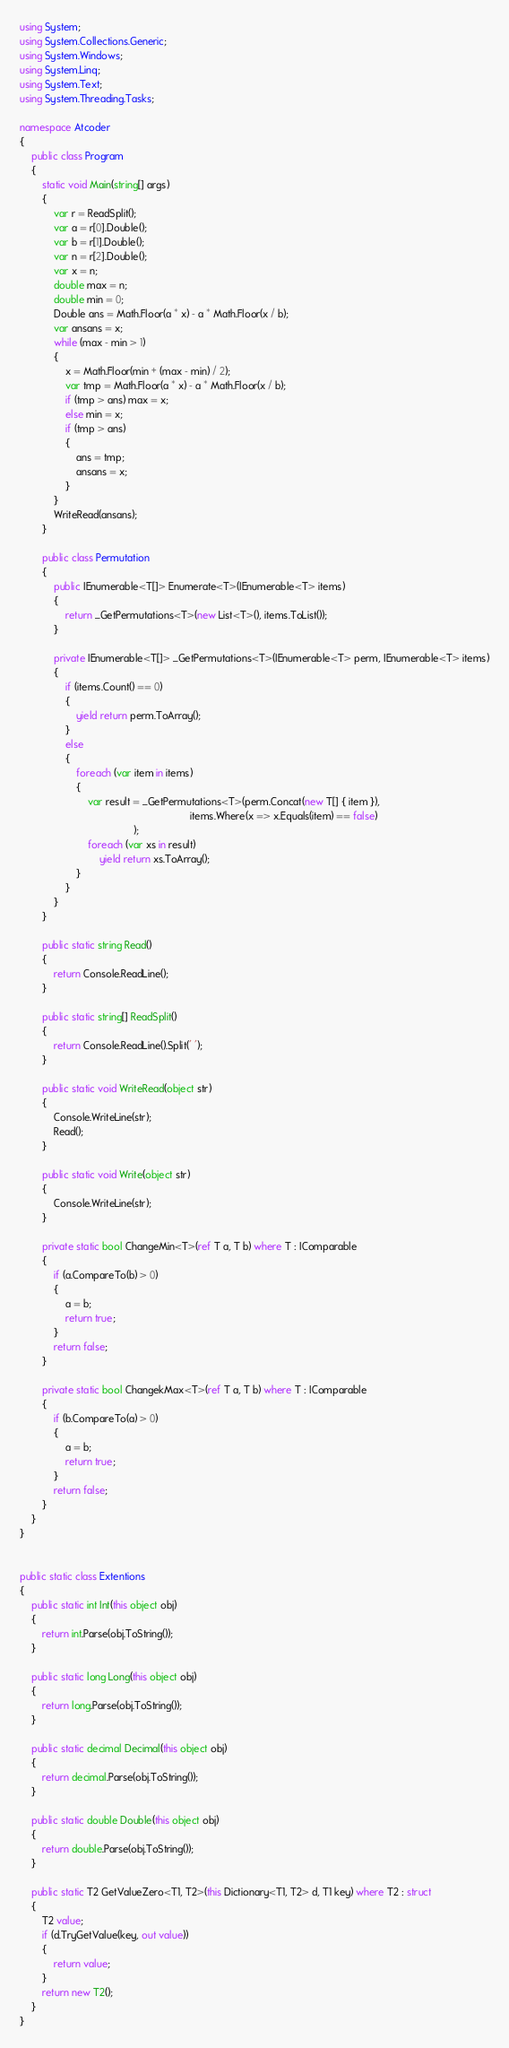<code> <loc_0><loc_0><loc_500><loc_500><_C#_>using System;
using System.Collections.Generic;
using System.Windows;
using System.Linq;
using System.Text;
using System.Threading.Tasks;

namespace Atcoder
{
    public class Program
    {
        static void Main(string[] args)
        {
            var r = ReadSplit();
            var a = r[0].Double();
            var b = r[1].Double();
            var n = r[2].Double();
            var x = n;
            double max = n;
            double min = 0;
            Double ans = Math.Floor(a * x) - a * Math.Floor(x / b);
            var ansans = x;
            while (max - min > 1)
            {
                x = Math.Floor(min + (max - min) / 2);
                var tmp = Math.Floor(a * x) - a * Math.Floor(x / b);
                if (tmp > ans) max = x;
                else min = x;
                if (tmp > ans)
                {
                    ans = tmp;
                    ansans = x;
                }
            }
            WriteRead(ansans);
        }

        public class Permutation
        {
            public IEnumerable<T[]> Enumerate<T>(IEnumerable<T> items)
            {
                return _GetPermutations<T>(new List<T>(), items.ToList());
            }

            private IEnumerable<T[]> _GetPermutations<T>(IEnumerable<T> perm, IEnumerable<T> items)
            {
                if (items.Count() == 0)
                {
                    yield return perm.ToArray();
                }
                else
                {
                    foreach (var item in items)
                    {
                        var result = _GetPermutations<T>(perm.Concat(new T[] { item }),
                                                            items.Where(x => x.Equals(item) == false)
                                        );
                        foreach (var xs in result)
                            yield return xs.ToArray();
                    }
                }
            }
        }

        public static string Read()
        {
            return Console.ReadLine();
        }

        public static string[] ReadSplit()
        {
            return Console.ReadLine().Split(' ');
        }

        public static void WriteRead(object str)
        {
            Console.WriteLine(str);
            Read();
        }

        public static void Write(object str)
        {
            Console.WriteLine(str);
        }

        private static bool ChangeMin<T>(ref T a, T b) where T : IComparable
        {
            if (a.CompareTo(b) > 0)
            {
                a = b;
                return true;
            }
            return false;
        }

        private static bool ChangekMax<T>(ref T a, T b) where T : IComparable
        {
            if (b.CompareTo(a) > 0)
            {
                a = b;
                return true;
            }
            return false;
        }
    }
}


public static class Extentions
{
    public static int Int(this object obj)
    {
        return int.Parse(obj.ToString());
    }

    public static long Long(this object obj)
    {
        return long.Parse(obj.ToString());
    }

    public static decimal Decimal(this object obj)
    {
        return decimal.Parse(obj.ToString());
    }

    public static double Double(this object obj)
    {
        return double.Parse(obj.ToString());
    }

    public static T2 GetValueZero<T1, T2>(this Dictionary<T1, T2> d, T1 key) where T2 : struct
    {
        T2 value;
        if (d.TryGetValue(key, out value))
        {
            return value;
        }
        return new T2();
    }
}

</code> 